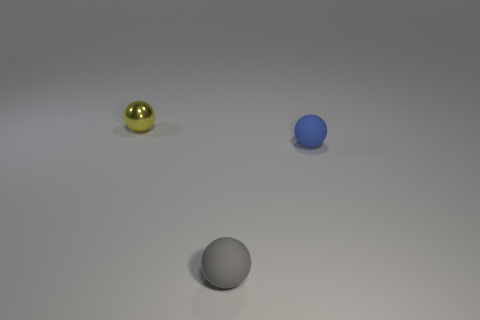Is there any other thing that is made of the same material as the yellow sphere?
Give a very brief answer. No. What color is the other small shiny thing that is the same shape as the gray thing?
Provide a succinct answer. Yellow. What is the shape of the small rubber object behind the small gray ball?
Keep it short and to the point. Sphere. How many tiny red things are the same shape as the small gray matte object?
Make the answer very short. 0. There is a thing on the right side of the gray rubber thing; is its color the same as the small ball that is on the left side of the gray ball?
Your answer should be compact. No. How many things are either small brown metallic objects or tiny yellow metallic things?
Keep it short and to the point. 1. How many gray balls have the same material as the blue thing?
Offer a terse response. 1. Is the number of small blue matte cubes less than the number of yellow objects?
Your answer should be compact. Yes. Are the thing that is to the right of the small gray thing and the tiny yellow ball made of the same material?
Give a very brief answer. No. How many balls are tiny shiny things or rubber objects?
Your answer should be very brief. 3. 